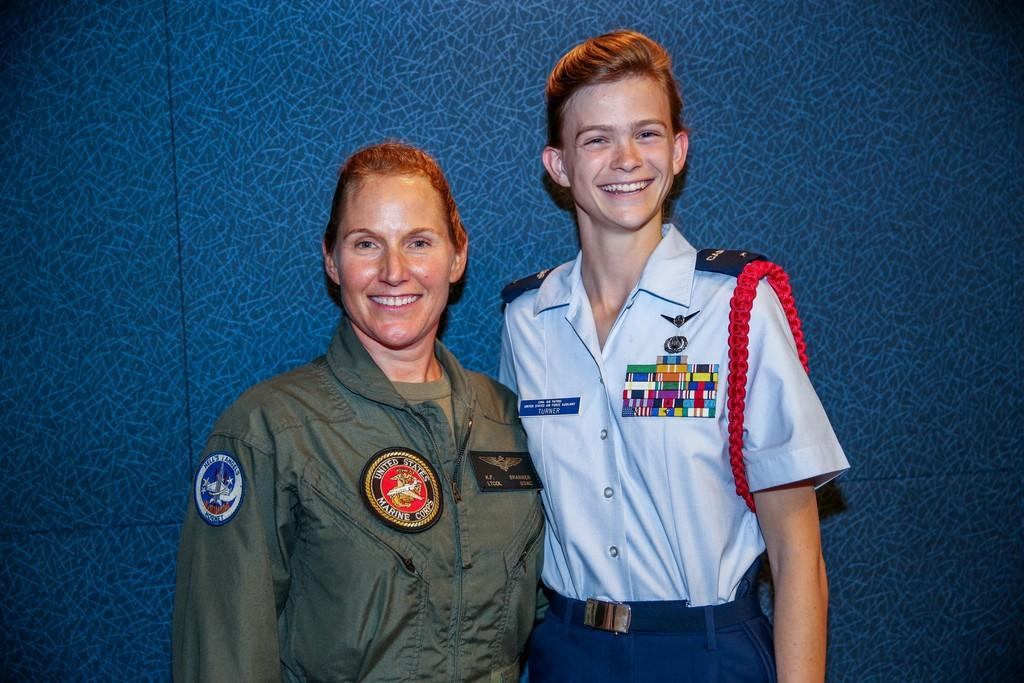How many individuals are present in the image? There are people in the image. Can you describe the relationship between the individuals? The people in the image are a couple. What is the emotional expression of the couple in the image? Both people are smiling. What do the couple believe in the image? There is no information about the couple's beliefs in the image. 